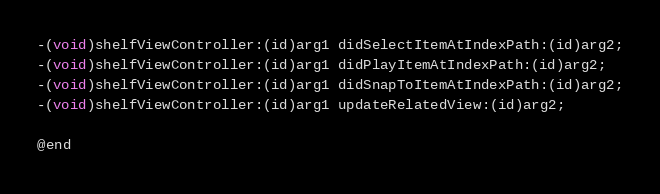Convert code to text. <code><loc_0><loc_0><loc_500><loc_500><_C_>-(void)shelfViewController:(id)arg1 didSelectItemAtIndexPath:(id)arg2;
-(void)shelfViewController:(id)arg1 didPlayItemAtIndexPath:(id)arg2;
-(void)shelfViewController:(id)arg1 didSnapToItemAtIndexPath:(id)arg2;
-(void)shelfViewController:(id)arg1 updateRelatedView:(id)arg2;

@end

</code> 